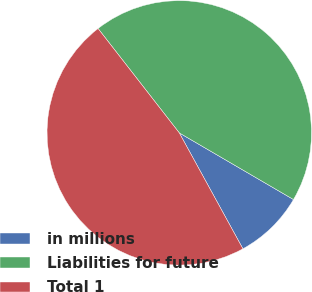Convert chart. <chart><loc_0><loc_0><loc_500><loc_500><pie_chart><fcel>in millions<fcel>Liabilities for future<fcel>Total 1<nl><fcel>8.6%<fcel>43.93%<fcel>47.46%<nl></chart> 